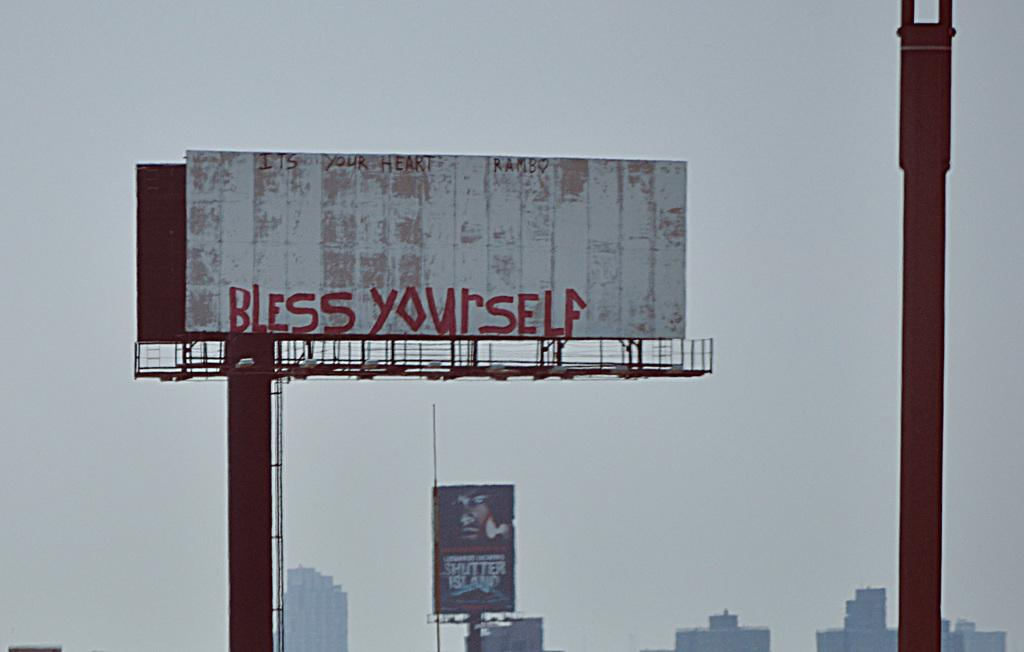<image>
Present a compact description of the photo's key features. A billboard says "Bless Yourself" written in red letters. 